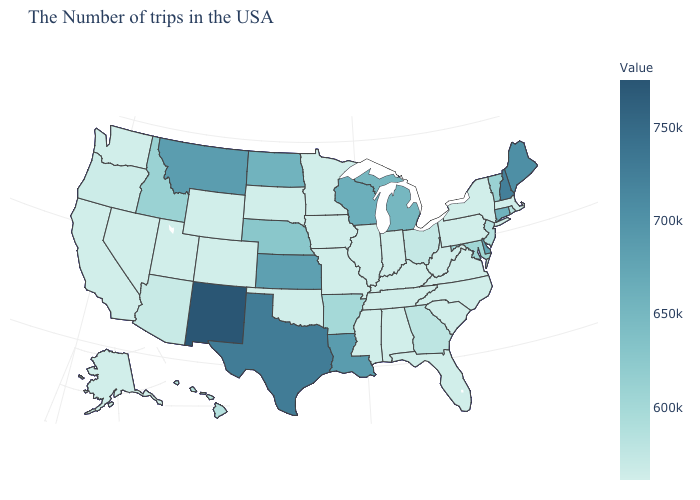Among the states that border Wyoming , which have the highest value?
Short answer required. Montana. Among the states that border Nevada , which have the highest value?
Answer briefly. Idaho. Is the legend a continuous bar?
Short answer required. Yes. Is the legend a continuous bar?
Short answer required. Yes. Which states have the lowest value in the South?
Be succinct. Virginia, North Carolina, South Carolina, West Virginia, Florida, Kentucky, Alabama, Tennessee, Mississippi, Oklahoma. Among the states that border Texas , which have the highest value?
Give a very brief answer. New Mexico. Which states have the lowest value in the USA?
Concise answer only. Massachusetts, New York, Pennsylvania, Virginia, North Carolina, South Carolina, West Virginia, Florida, Kentucky, Indiana, Alabama, Tennessee, Illinois, Mississippi, Missouri, Minnesota, Iowa, Oklahoma, South Dakota, Wyoming, Colorado, Utah, Nevada, California, Washington, Alaska. 